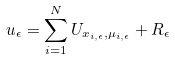<formula> <loc_0><loc_0><loc_500><loc_500>u _ { \epsilon } = \sum _ { i = 1 } ^ { N } U _ { x _ { i , \epsilon } , \mu _ { i , \epsilon } } + R _ { \epsilon }</formula> 